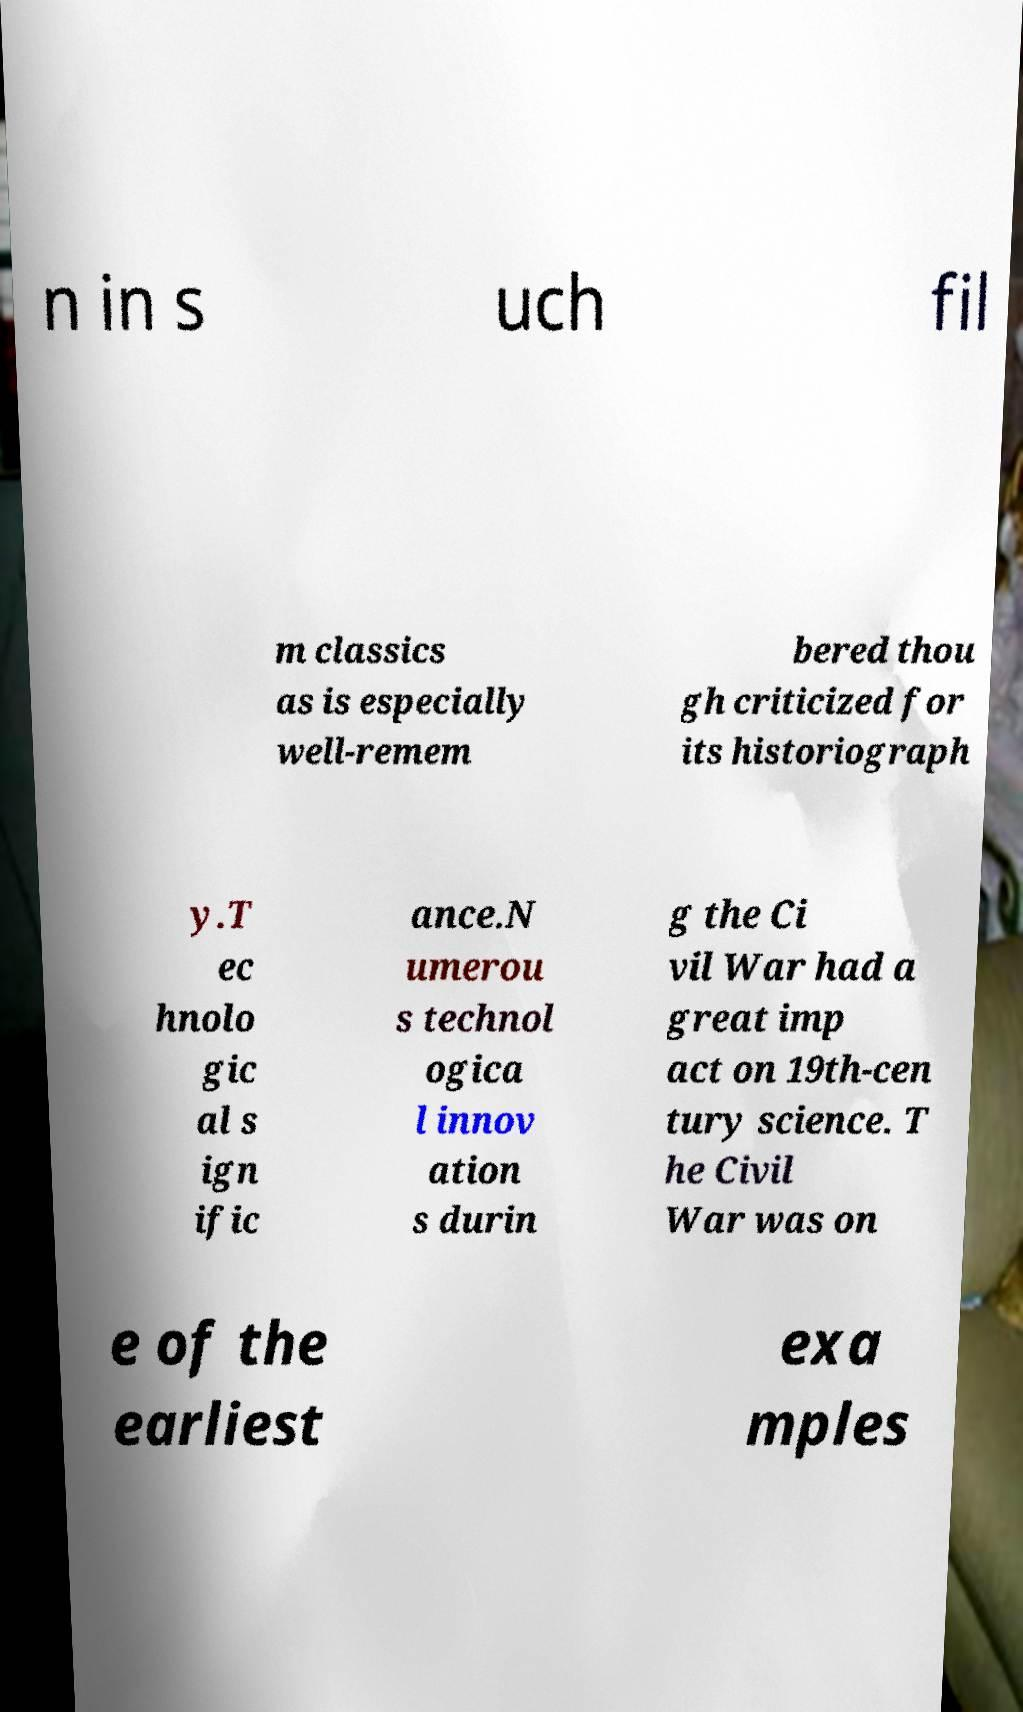Please identify and transcribe the text found in this image. n in s uch fil m classics as is especially well-remem bered thou gh criticized for its historiograph y.T ec hnolo gic al s ign ific ance.N umerou s technol ogica l innov ation s durin g the Ci vil War had a great imp act on 19th-cen tury science. T he Civil War was on e of the earliest exa mples 